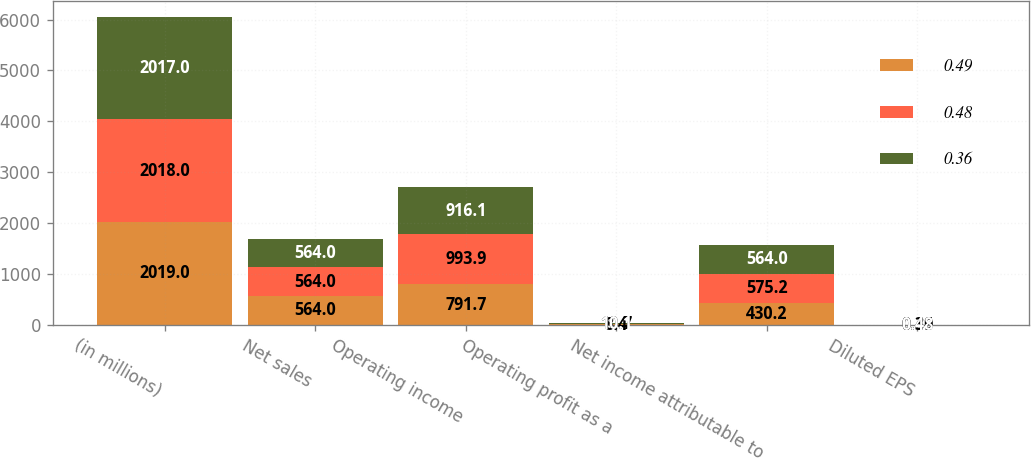Convert chart. <chart><loc_0><loc_0><loc_500><loc_500><stacked_bar_chart><ecel><fcel>(in millions)<fcel>Net sales<fcel>Operating income<fcel>Operating profit as a<fcel>Net income attributable to<fcel>Diluted EPS<nl><fcel>0.49<fcel>2019<fcel>564<fcel>791.7<fcel>8.4<fcel>430.2<fcel>0.36<nl><fcel>0.48<fcel>2018<fcel>564<fcel>993.9<fcel>10.7<fcel>575.2<fcel>0.49<nl><fcel>0.36<fcel>2017<fcel>564<fcel>916.1<fcel>10.1<fcel>564<fcel>0.48<nl></chart> 